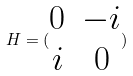Convert formula to latex. <formula><loc_0><loc_0><loc_500><loc_500>H = ( \begin{matrix} 0 & - i \\ i & 0 \end{matrix} )</formula> 